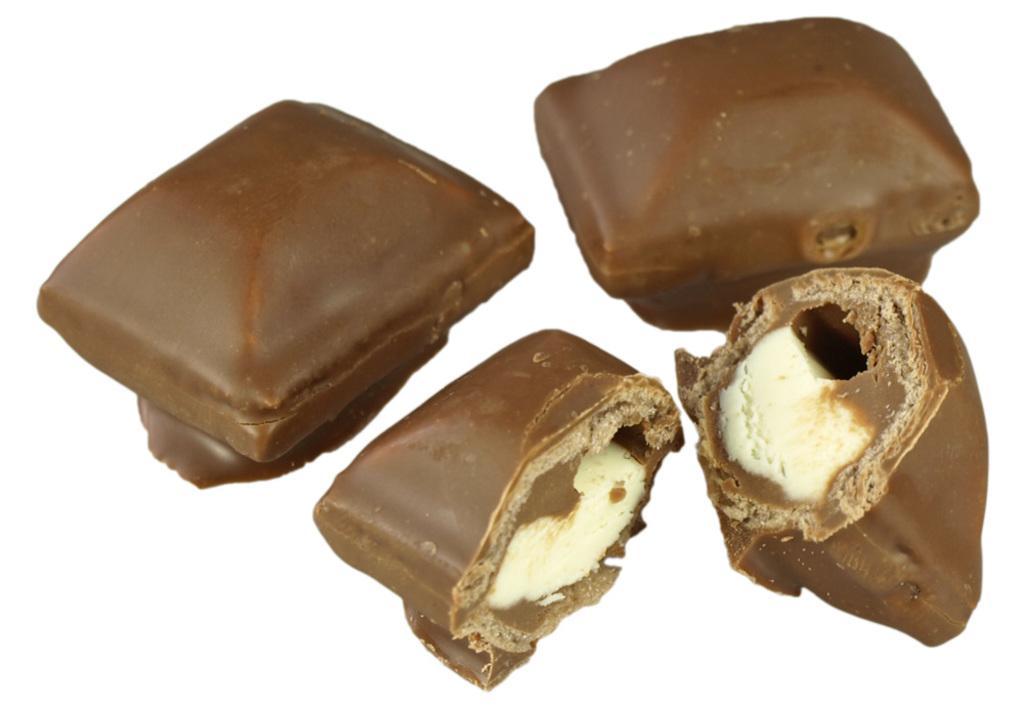Please provide a concise description of this image. In this picture we can see chocolate pieces. 